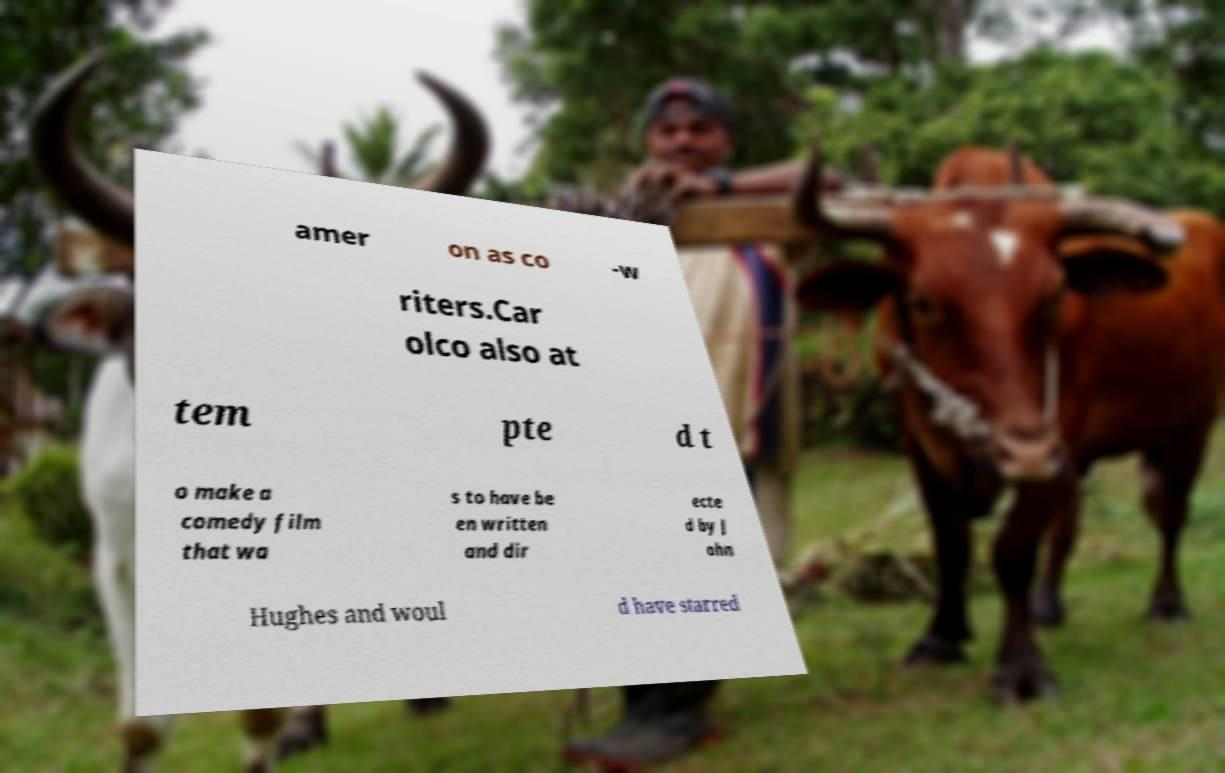For documentation purposes, I need the text within this image transcribed. Could you provide that? amer on as co -w riters.Car olco also at tem pte d t o make a comedy film that wa s to have be en written and dir ecte d by J ohn Hughes and woul d have starred 